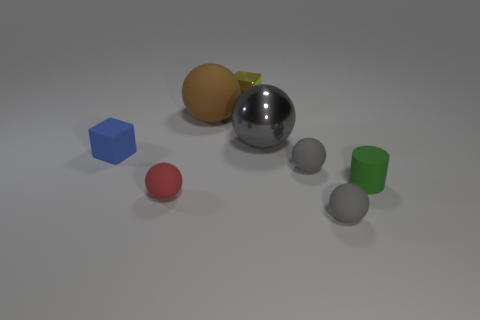There is a large matte ball that is on the left side of the tiny rubber cylinder; does it have the same color as the metallic ball?
Provide a succinct answer. No. Is the small yellow cube made of the same material as the ball that is on the left side of the big brown sphere?
Your response must be concise. No. The tiny yellow object that is to the right of the blue object has what shape?
Offer a very short reply. Cube. How many other things are there of the same material as the yellow block?
Ensure brevity in your answer.  1. What is the size of the matte cube?
Provide a short and direct response. Small. What number of other objects are there of the same color as the tiny matte cylinder?
Ensure brevity in your answer.  0. What color is the ball that is both right of the big brown matte thing and behind the tiny blue matte thing?
Give a very brief answer. Gray. What number of brown rubber spheres are there?
Provide a short and direct response. 1. Is the blue thing made of the same material as the green object?
Provide a short and direct response. Yes. What is the shape of the metallic thing that is in front of the cube that is on the right side of the small block that is in front of the yellow object?
Make the answer very short. Sphere. 